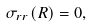Convert formula to latex. <formula><loc_0><loc_0><loc_500><loc_500>\sigma _ { r r } ( R ) = 0 ,</formula> 